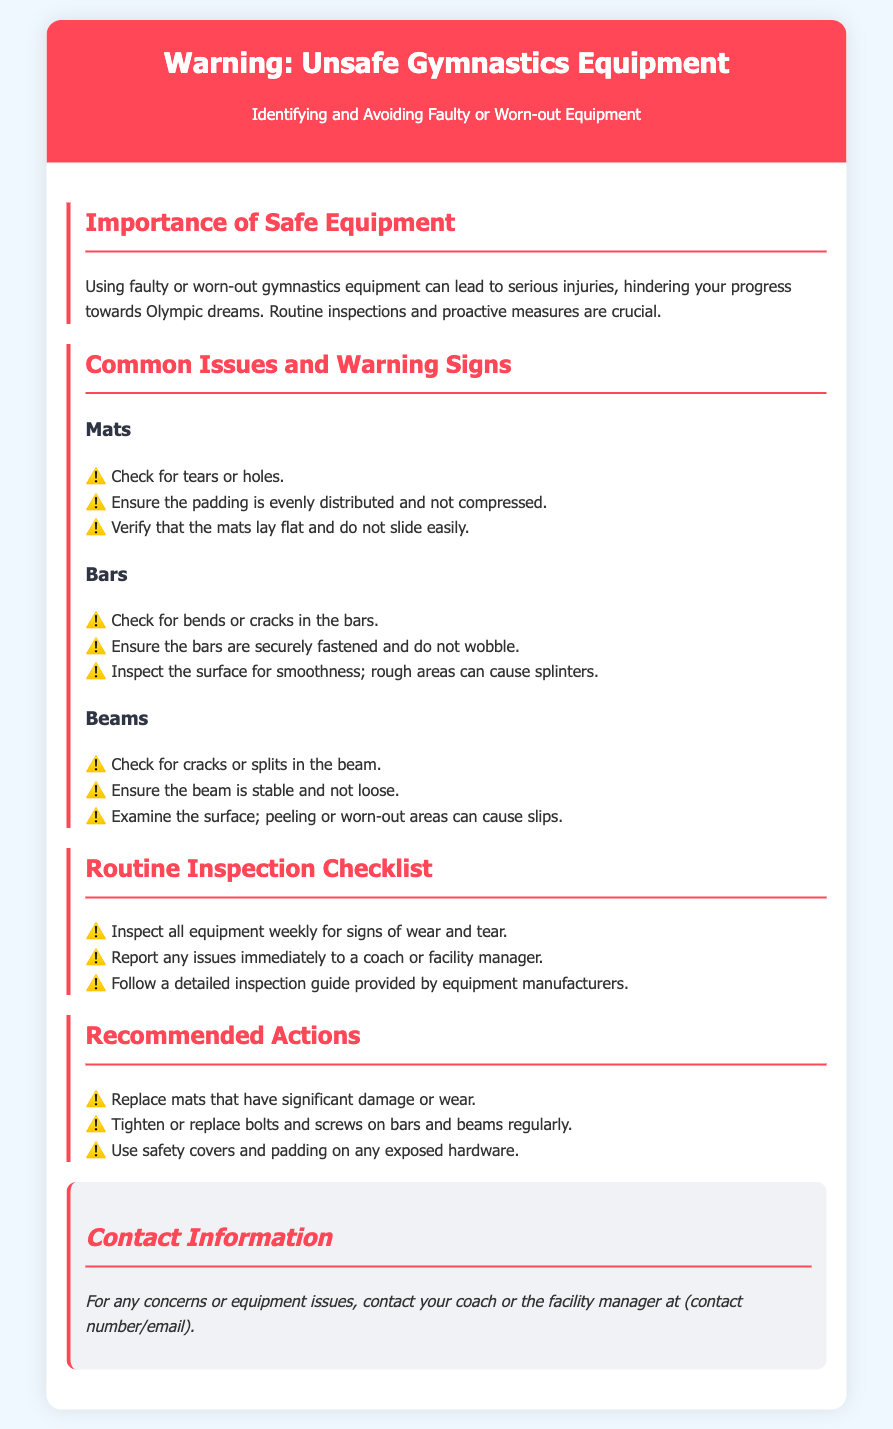What is the title of the document? The title is explicitly stated at the beginning of the document.
Answer: Warning: Unsafe Gymnastics Equipment How often should equipment be inspected? The document specifies a frequency of inspections within a checklist.
Answer: Weekly What should you check for in mats? There is a list of potential issues with mats mentioned in the document.
Answer: Tears or holes What is one recommended action for bars? The document provides specific recommended actions for equipment maintenance.
Answer: Tighten or replace bolts and screws What is a warning sign for beams? The document outlines issues to look for specifically with beams.
Answer: Cracks or splits Who should you report equipment issues to? The document includes instructions on who to contact for reporting issues.
Answer: Coach or facility manager Why is routine inspection important? The document discusses the significance of inspections in relation to safety.
Answer: Prevent injuries What should be ensured about bars during inspection? The document lists specific checks for bars that must be performed.
Answer: Securely fastened and not wobble 